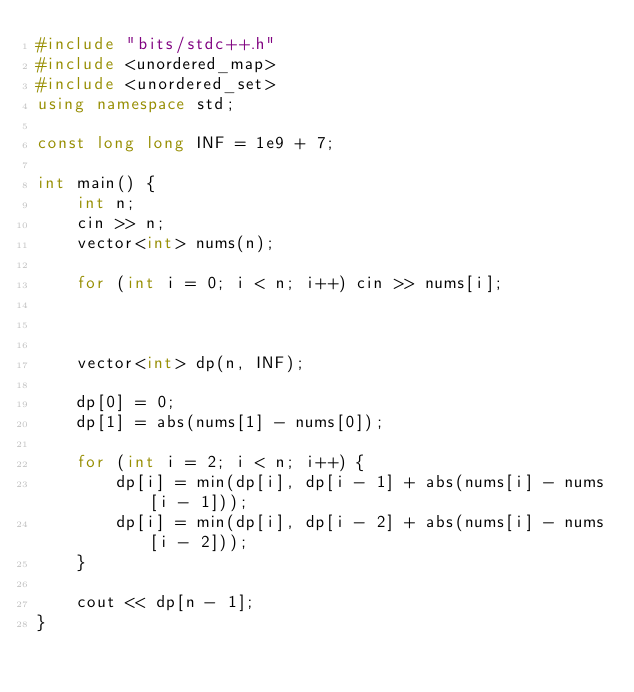<code> <loc_0><loc_0><loc_500><loc_500><_C++_>#include "bits/stdc++.h"
#include <unordered_map>
#include <unordered_set>
using namespace std;

const long long INF = 1e9 + 7;

int main() {
	int n;
	cin >> n;
	vector<int> nums(n);

	for (int i = 0; i < n; i++) cin >> nums[i];

	

	vector<int> dp(n, INF);

	dp[0] = 0;
	dp[1] = abs(nums[1] - nums[0]);

	for (int i = 2; i < n; i++) {
		dp[i] = min(dp[i], dp[i - 1] + abs(nums[i] - nums[i - 1]));
		dp[i] = min(dp[i], dp[i - 2] + abs(nums[i] - nums[i - 2]));
	}

	cout << dp[n - 1];
}
</code> 